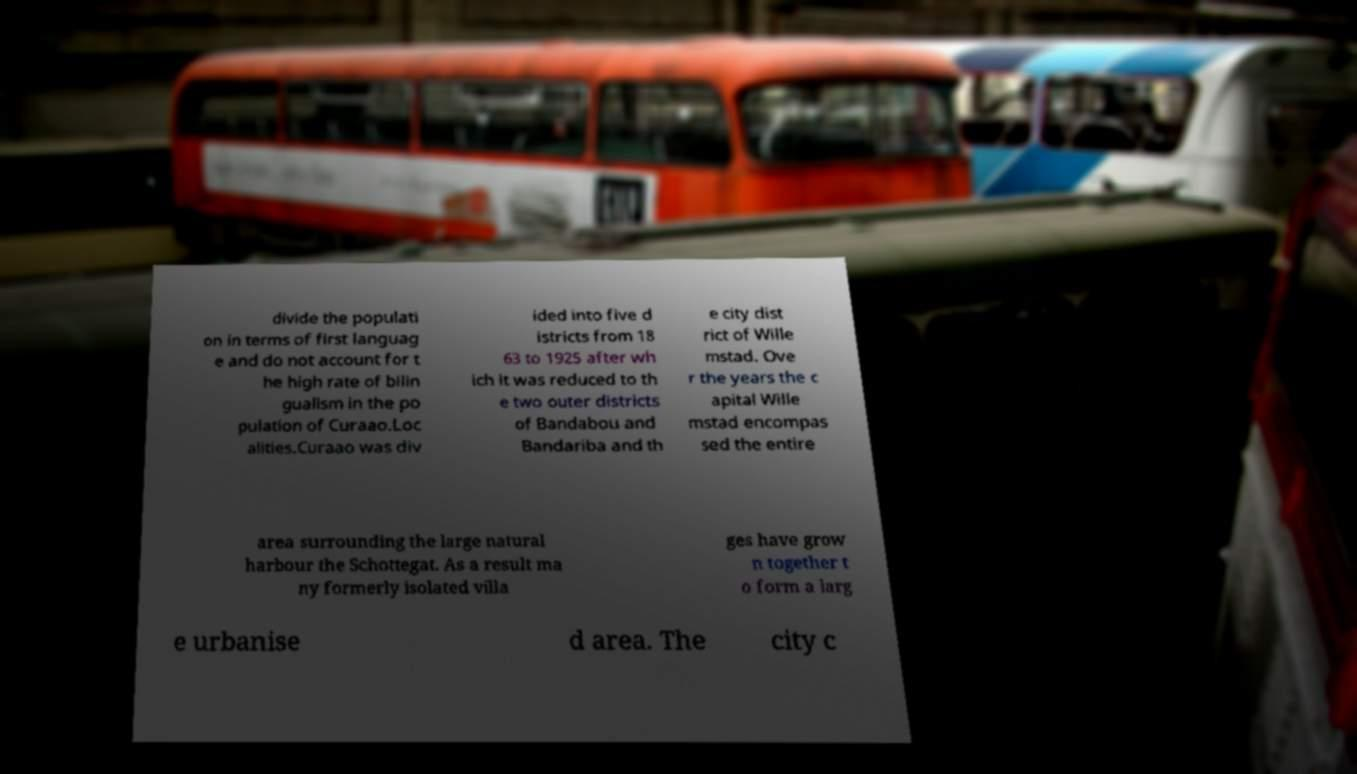For documentation purposes, I need the text within this image transcribed. Could you provide that? divide the populati on in terms of first languag e and do not account for t he high rate of bilin gualism in the po pulation of Curaao.Loc alities.Curaao was div ided into five d istricts from 18 63 to 1925 after wh ich it was reduced to th e two outer districts of Bandabou and Bandariba and th e city dist rict of Wille mstad. Ove r the years the c apital Wille mstad encompas sed the entire area surrounding the large natural harbour the Schottegat. As a result ma ny formerly isolated villa ges have grow n together t o form a larg e urbanise d area. The city c 